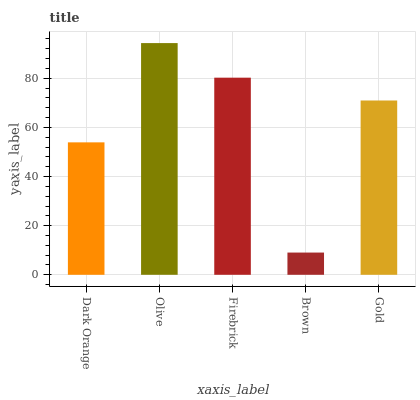Is Brown the minimum?
Answer yes or no. Yes. Is Olive the maximum?
Answer yes or no. Yes. Is Firebrick the minimum?
Answer yes or no. No. Is Firebrick the maximum?
Answer yes or no. No. Is Olive greater than Firebrick?
Answer yes or no. Yes. Is Firebrick less than Olive?
Answer yes or no. Yes. Is Firebrick greater than Olive?
Answer yes or no. No. Is Olive less than Firebrick?
Answer yes or no. No. Is Gold the high median?
Answer yes or no. Yes. Is Gold the low median?
Answer yes or no. Yes. Is Brown the high median?
Answer yes or no. No. Is Firebrick the low median?
Answer yes or no. No. 